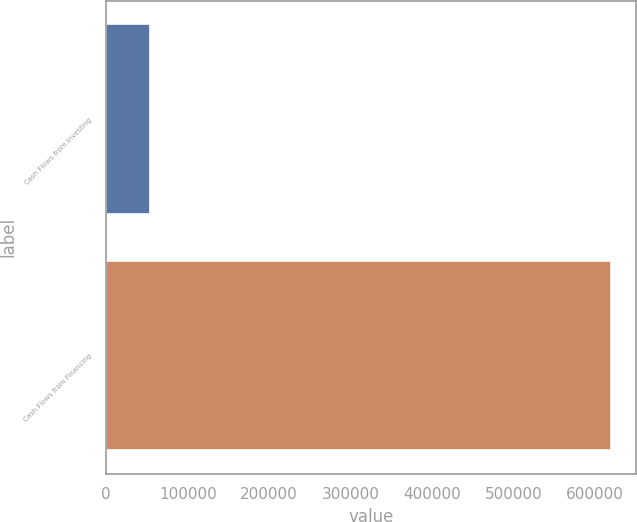Convert chart to OTSL. <chart><loc_0><loc_0><loc_500><loc_500><bar_chart><fcel>Cash Flows from Investing<fcel>Cash Flows from Financing<nl><fcel>53103<fcel>619704<nl></chart> 